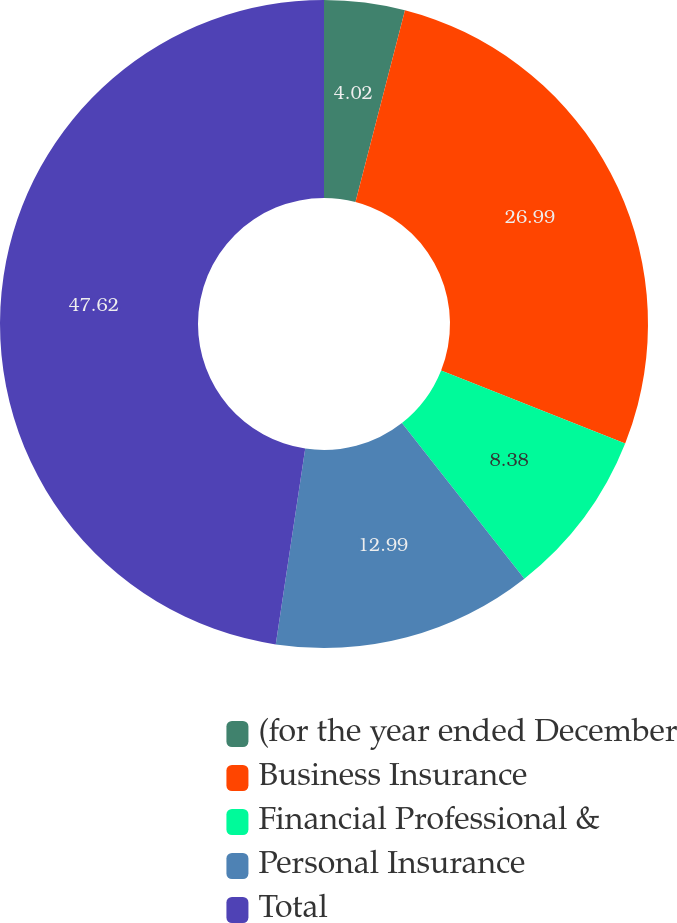Convert chart. <chart><loc_0><loc_0><loc_500><loc_500><pie_chart><fcel>(for the year ended December<fcel>Business Insurance<fcel>Financial Professional &<fcel>Personal Insurance<fcel>Total<nl><fcel>4.02%<fcel>26.99%<fcel>8.38%<fcel>12.99%<fcel>47.62%<nl></chart> 